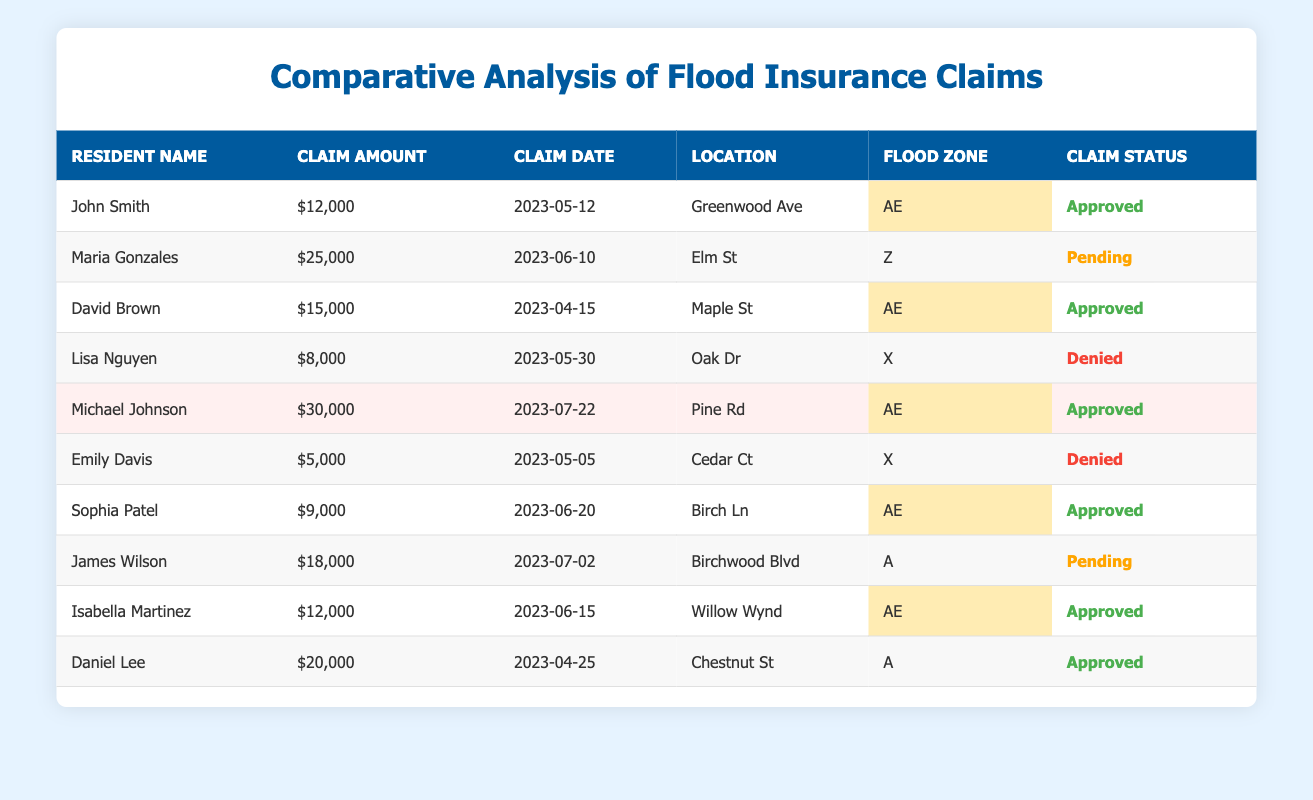What is the total claim amount for approved claims? The approved claims are from John Smith ($12,000), David Brown ($15,000), Michael Johnson ($30,000), Sophia Patel ($9,000), Isabella Martinez ($12,000), and Daniel Lee ($20,000). Adding these amounts together gives (12,000 + 15,000 + 30,000 + 9,000 + 12,000 + 20,000) = $98,000.
Answer: $98,000 How many claims were denied? The claims denied are from Lisa Nguyen and Emily Davis. There are 2 residents whose claims were denied.
Answer: 2 Which resident has the highest claim amount and what is the amount? The resident with the highest claim amount is Michael Johnson with a claim amount of $30,000.
Answer: Michael Johnson, $30,000 What is the claim status of Maria Gonzales? Maria Gonzales' claim status is pending according to the table.
Answer: Pending How many residents filed claims in flood zone AE? The residents in flood zone AE are John Smith, David Brown, Michael Johnson, Sophia Patel, and Isabella Martinez. Count them, there are 5 residents.
Answer: 5 What is the average claim amount for all residents? The total claim amount is ($12,000 + $25,000 + $15,000 + $8,000 + $30,000 + $5,000 + $9,000 + $18,000 + $12,000 + $20,000) = $ 144,000. There are 10 residents, so the average claim amount is $144,000 / 10 = $14,400.
Answer: $14,400 Is there any resident who has a claim amount of $8,000? Yes, Lisa Nguyen has a claim amount of $8,000, which is shown in the table.
Answer: Yes Which flood zone has the most claims? The flood zone AE has 5 claims (from John Smith, David Brown, Michael Johnson, Sophia Patel, and Isabella Martinez), which is more than any other flood zone.
Answer: AE Are there more approved claims or denied claims? There are 6 approved claims (from John Smith, David Brown, Michael Johnson, Sophia Patel, Isabella Martinez, and Daniel Lee) and 2 denied claims (from Lisa Nguyen and Emily Davis). Thus, there are more approved claims.
Answer: Approved claims are more What is the total sum of the claim amounts for pending claims? The pending claims are from Maria Gonzales ($25,000) and James Wilson ($18,000). Adding these gives (25,000 + 18,000) = $43,000.
Answer: $43,000 Has any resident from flood zone Z had their claim denied? No, there are no claims from flood zone Z that have been denied. Maria Gonzales' claim is pending, not denied.
Answer: No 